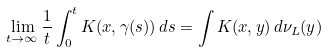<formula> <loc_0><loc_0><loc_500><loc_500>\lim _ { t \rightarrow \infty } \frac { 1 } { t } \int _ { 0 } ^ { t } K ( x , \gamma ( s ) ) \, d s = \int K ( x , y ) \, d \nu _ { L } ( y )</formula> 